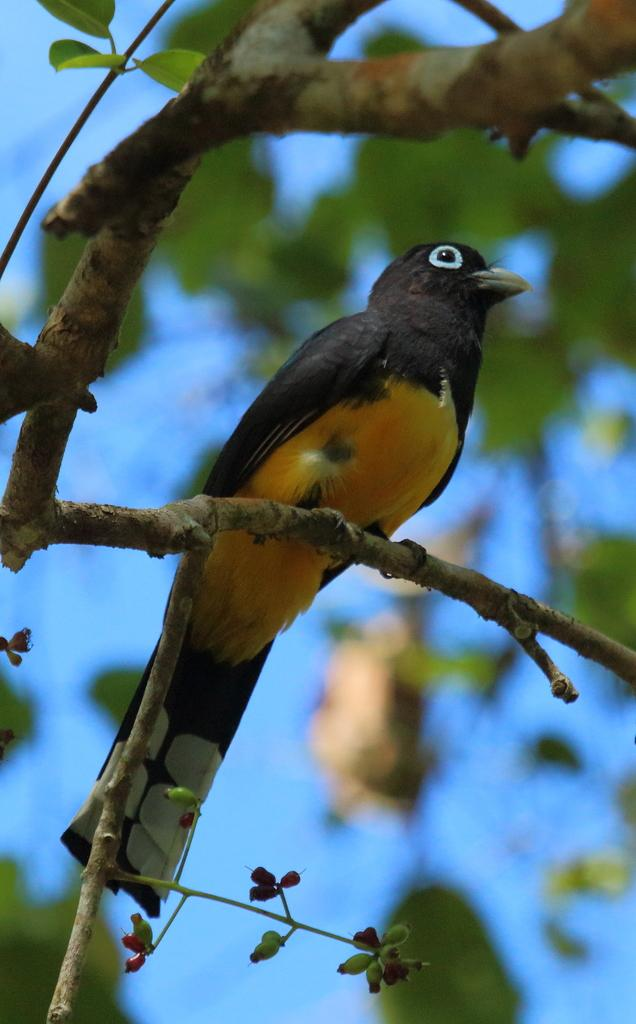What type of animal can be seen in the image? There is a bird in the image. Where is the bird located? The bird is sitting on a branch of a tree. What can be seen in the background of the image? The sky is visible in the background of the image. How would you describe the background of the image? The background of the image is blurred. What does the cat do after the bird flies away in the image? There is no cat present in the image, and therefore no such interaction can be observed. 